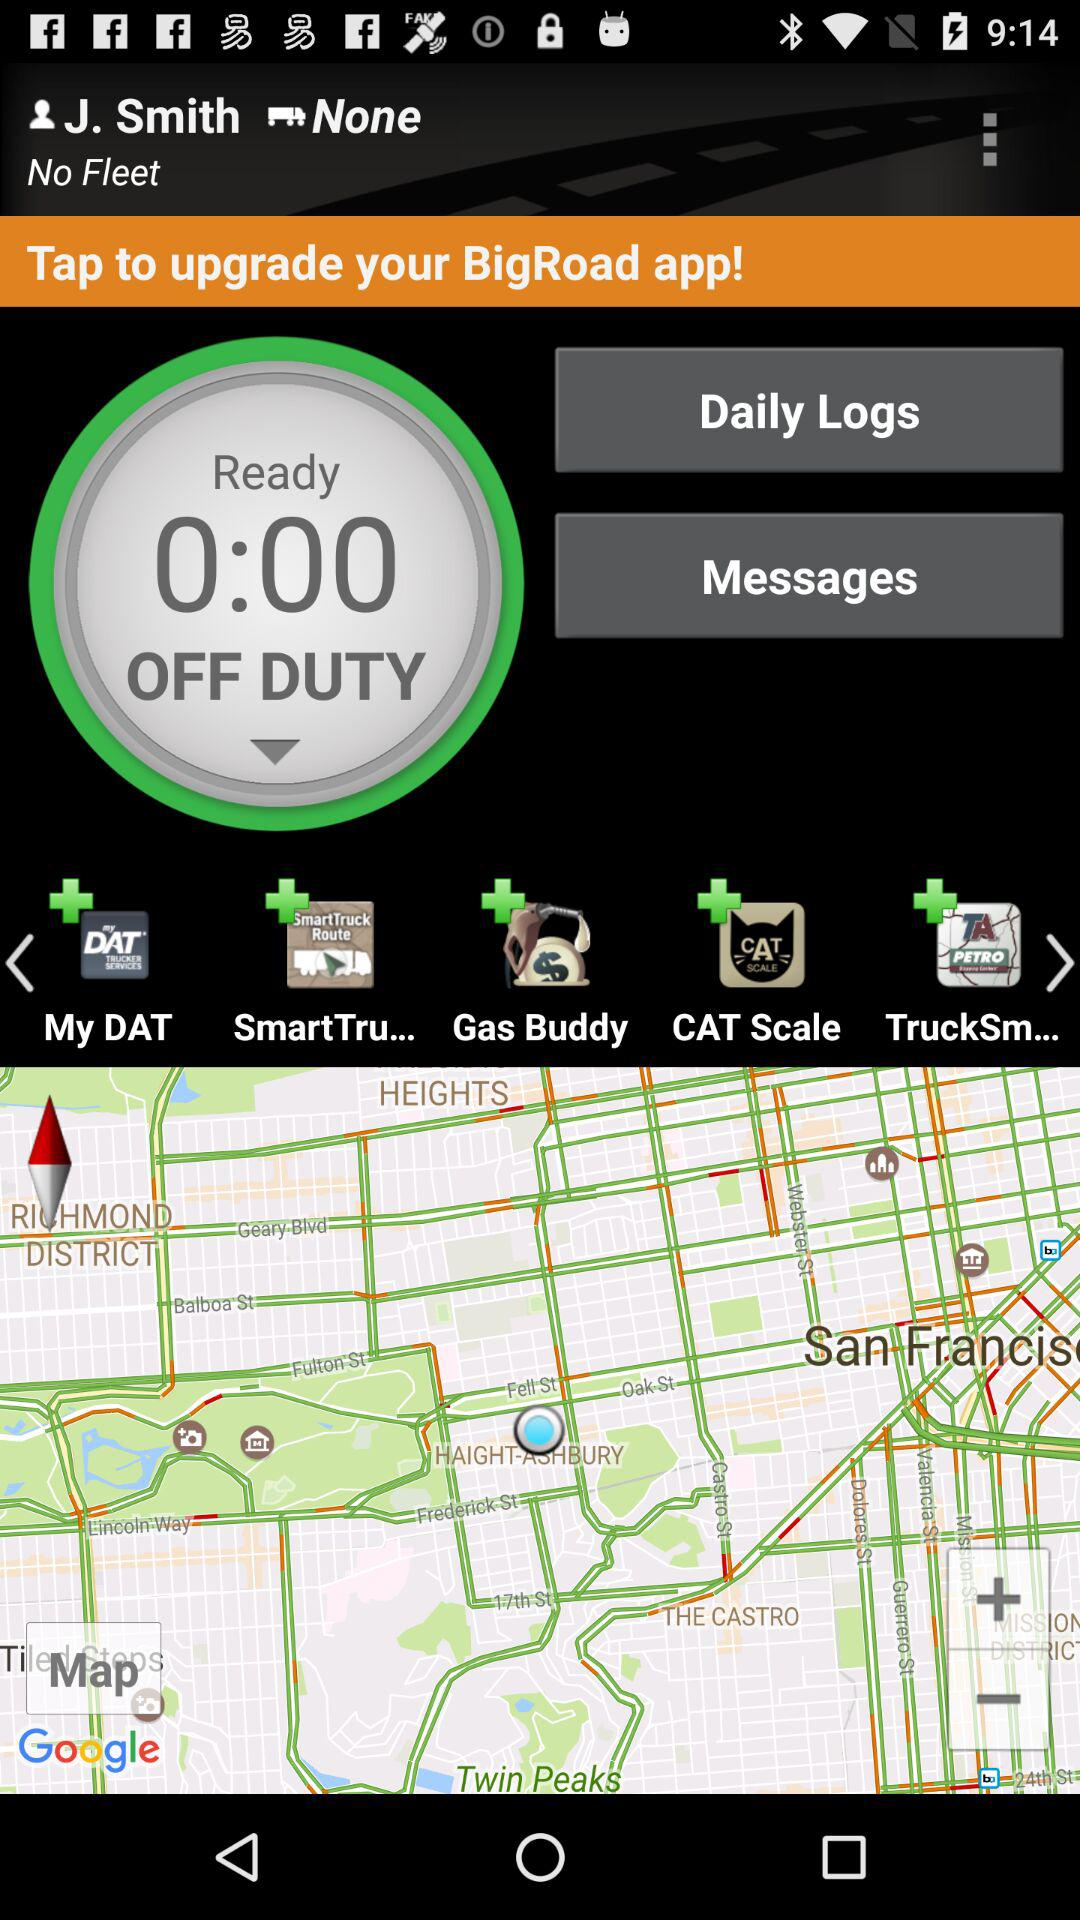What is the user name? The user name is J. Smith. 